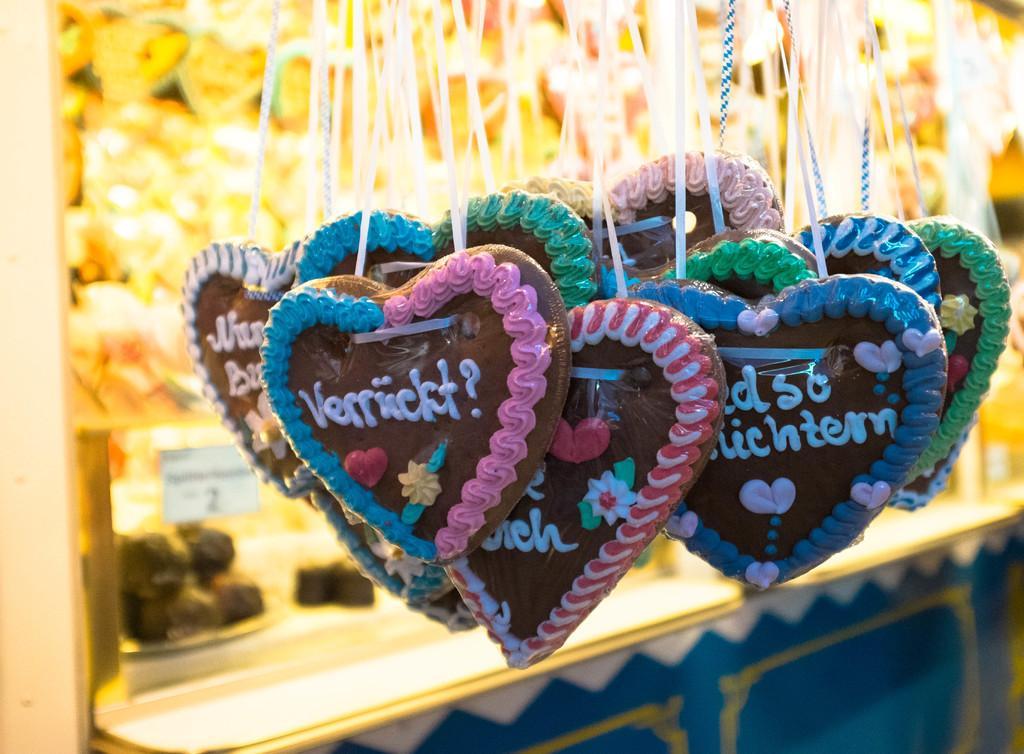In one or two sentences, can you explain what this image depicts? In the picture I can see objects hanging to an object. On these objects I can see something written on them. The background of the image is blurred. 